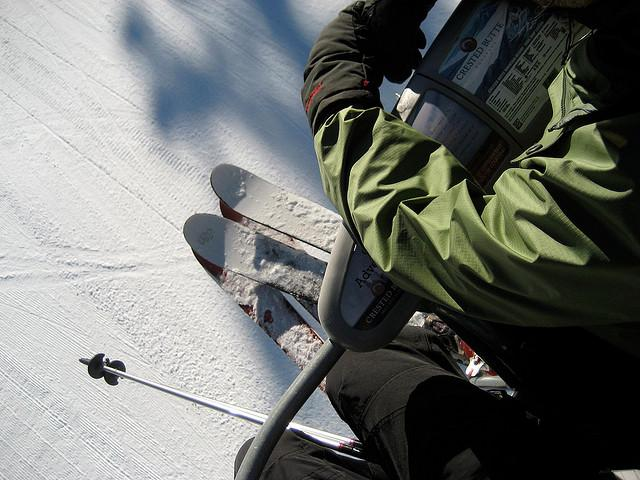What is the person near? snow 